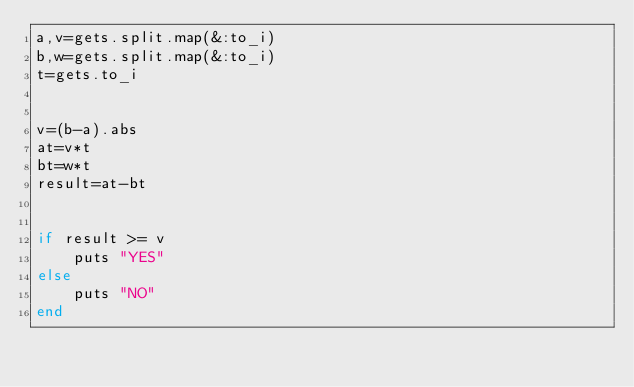<code> <loc_0><loc_0><loc_500><loc_500><_Ruby_>a,v=gets.split.map(&:to_i)
b,w=gets.split.map(&:to_i)
t=gets.to_i


v=(b-a).abs
at=v*t
bt=w*t
result=at-bt


if result >= v
    puts "YES"
else
    puts "NO"
end
</code> 